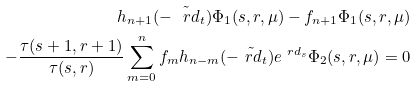<formula> <loc_0><loc_0><loc_500><loc_500>h _ { n + 1 } ( - \tilde { \ r d } _ { t } ) \Phi _ { 1 } ( s , r , \mu ) - f _ { n + 1 } \Phi _ { 1 } ( s , r , \mu ) \\ - \frac { \tau ( s + 1 , r + 1 ) } { \tau ( s , r ) } \sum _ { m = 0 } ^ { n } f _ { m } h _ { n - m } ( - \tilde { \ r d } _ { t } ) e ^ { \ r d _ { s } } \Phi _ { 2 } ( s , r , \mu ) = 0</formula> 